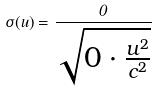Convert formula to latex. <formula><loc_0><loc_0><loc_500><loc_500>\sigma ( u ) = \frac { 0 } { \sqrt { 0 \cdot \frac { u ^ { 2 } } { c ^ { 2 } } } }</formula> 